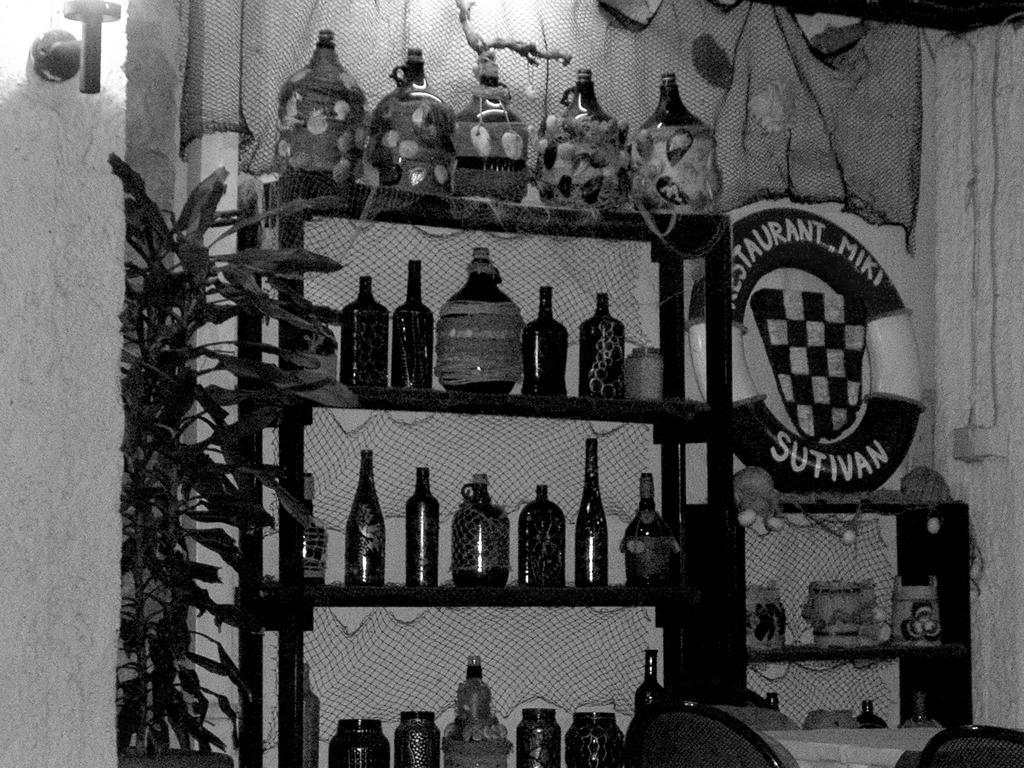Please provide a concise description of this image. This is a black and white picture. I can see glass bottles arranged in an order in the rack and on the rack, there is a plant, a safety tube, there are chairs, table, there are some other items in the another rack, and in the background there is a light and a wall. 